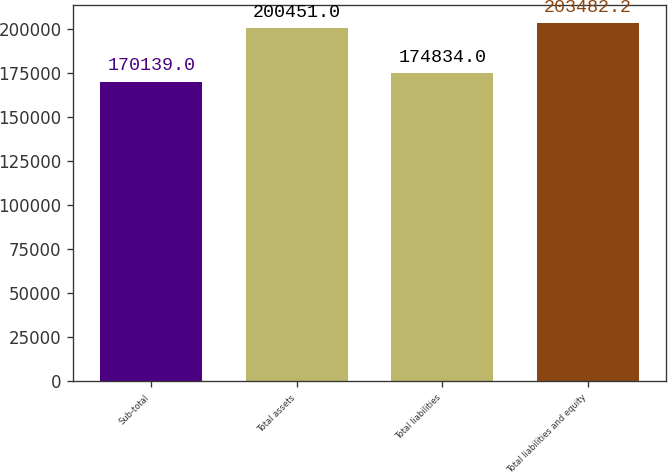<chart> <loc_0><loc_0><loc_500><loc_500><bar_chart><fcel>Sub-total<fcel>Total assets<fcel>Total liabilities<fcel>Total liabilities and equity<nl><fcel>170139<fcel>200451<fcel>174834<fcel>203482<nl></chart> 